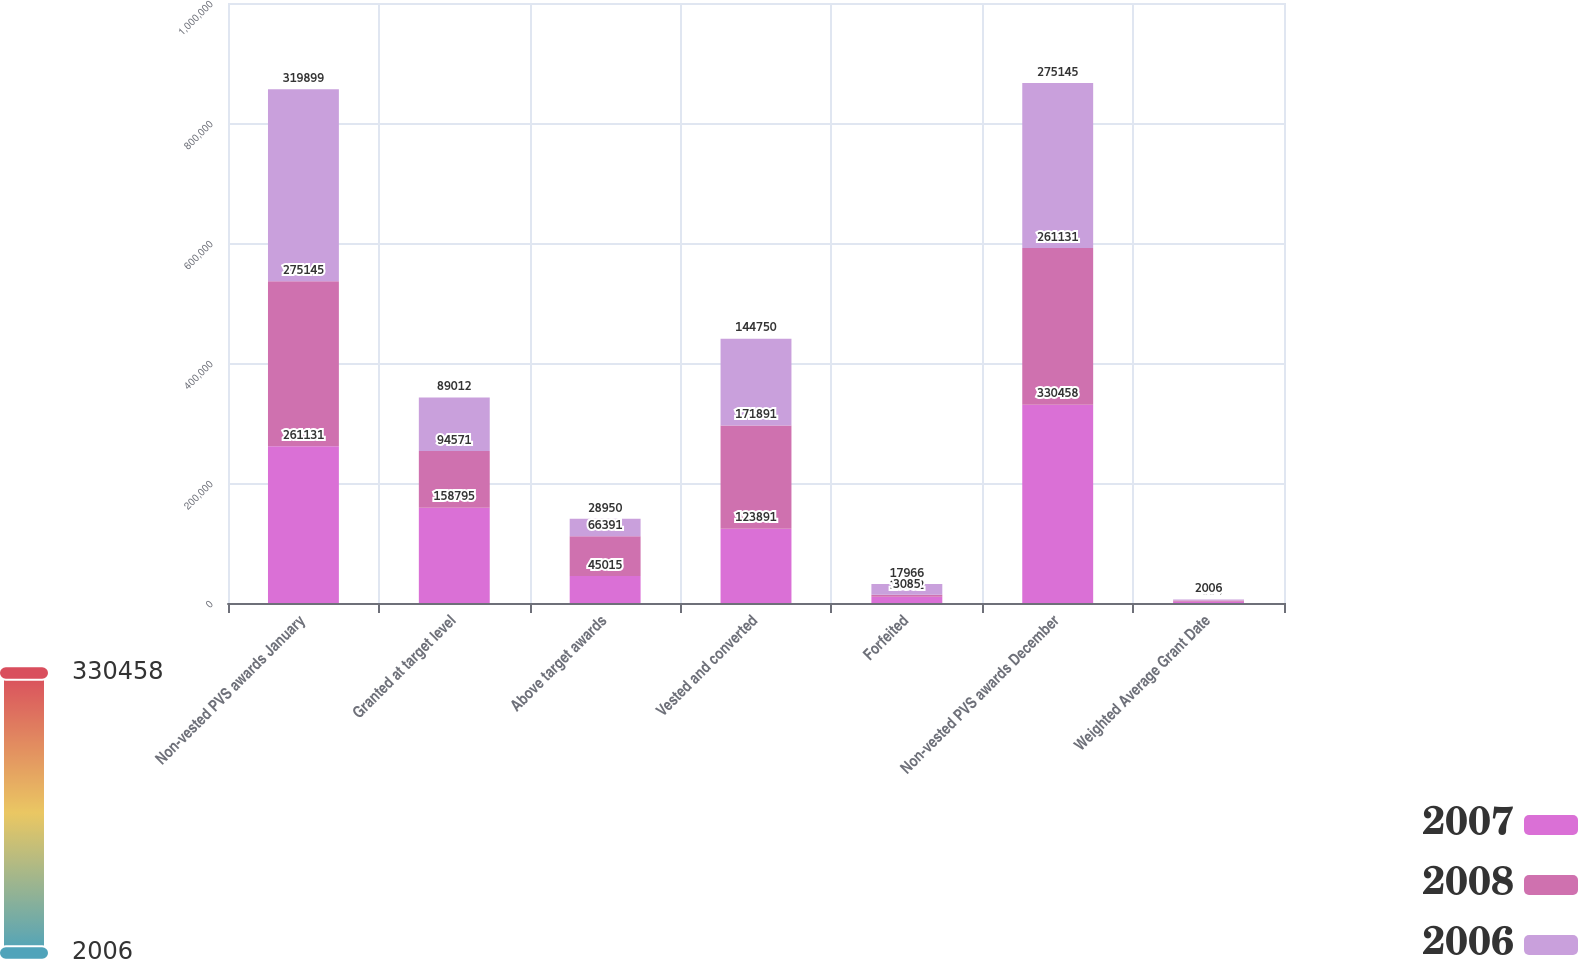Convert chart to OTSL. <chart><loc_0><loc_0><loc_500><loc_500><stacked_bar_chart><ecel><fcel>Non-vested PVS awards January<fcel>Granted at target level<fcel>Above target awards<fcel>Vested and converted<fcel>Forfeited<fcel>Non-vested PVS awards December<fcel>Weighted Average Grant Date<nl><fcel>2007<fcel>261131<fcel>158795<fcel>45015<fcel>123891<fcel>10592<fcel>330458<fcel>2008<nl><fcel>2008<fcel>275145<fcel>94571<fcel>66391<fcel>171891<fcel>3085<fcel>261131<fcel>2007<nl><fcel>2006<fcel>319899<fcel>89012<fcel>28950<fcel>144750<fcel>17966<fcel>275145<fcel>2006<nl></chart> 